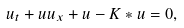Convert formula to latex. <formula><loc_0><loc_0><loc_500><loc_500>u _ { t } + u u _ { x } + u - K * u = 0 ,</formula> 